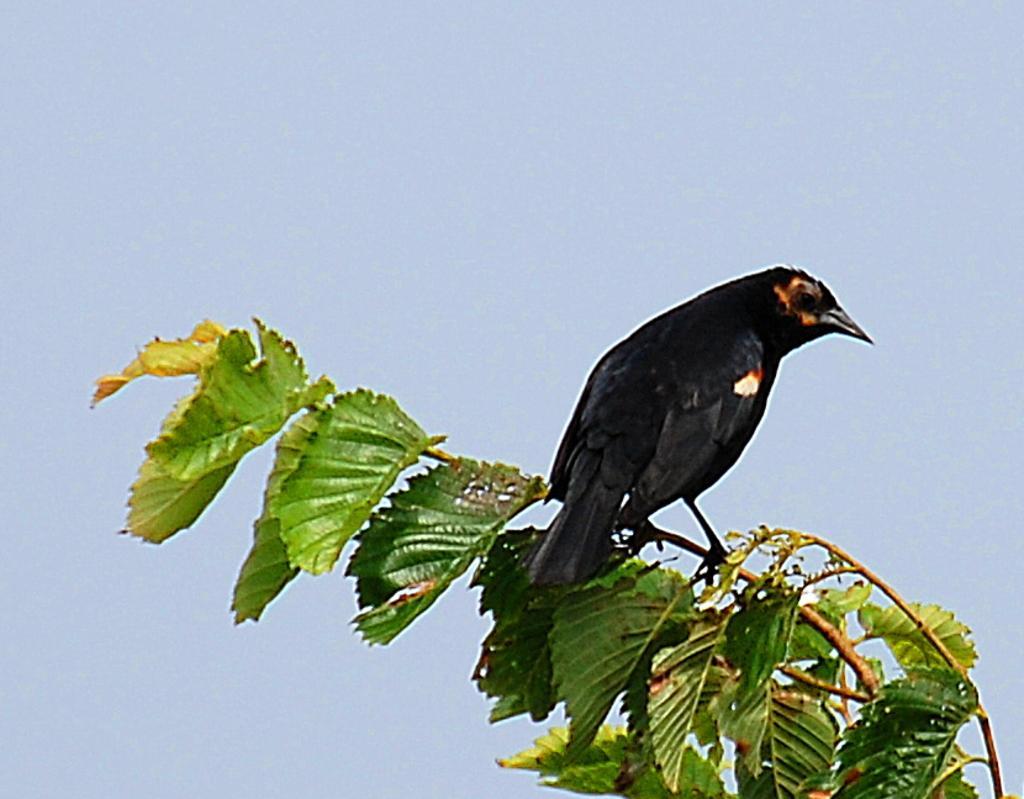Please provide a concise description of this image. In the foreground of this image, there is a black bird on a branch and we can also see few leaves to the branch. In the background, there is the sky. 